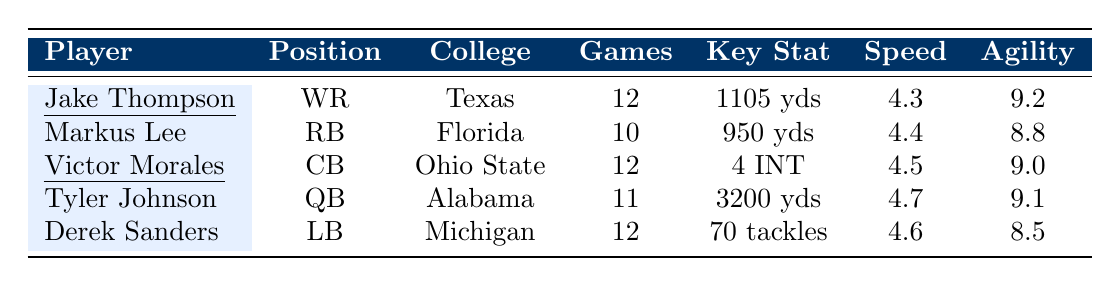What is the speed rating of Jake Thompson? The table provides a speed rating for each player. For Jake Thompson, the speed rating indicated in the row is 4.3.
Answer: 4.3 How many touchdowns did Tyler Johnson score? Looking at Tyler Johnson's row in the table, the number of touchdowns listed is 30.
Answer: 30 Which player had the most rushing attempts, and how many did they have? The table shows Markus Lee as the only player with rushing attempts listed, which is 180. None of the other players have this statistic, making him the player with the most attempts.
Answer: Markus Lee, 180 Who played the most games and how many games did they play? By examining the table, both Jake Thompson and Derek Sanders played 12 games, which is the highest number listed among all players.
Answer: Jake Thompson and Derek Sanders, 12 games What is the average tackles per game for Derek Sanders? The table provides an average tackles per game for Derek Sanders, which is stated as 5.8. This is the value we will use to answer the question.
Answer: 5.8 Is Jake Thompson's average yards per game higher than Markus Lee's? The average yards per game for Jake Thompson is 92, while Markus Lee's is 95. Since 92 < 95, Jake Thompson's average is not higher than Markus Lee's.
Answer: No How many total touchdowns were scored by the players listed in the table? To find the total touchdowns, we need to sum the touchdowns for each player. This gives us 12 (Thompson) + 8 (Lee) + 0 (Morales) + 30 (Johnson) + 1 (Sanders) = 51.
Answer: 51 Which player's agility rating is the highest and what is that value? Checking the agility ratings in the table, Jake Thompson has the highest rating at 9.2.
Answer: Jake Thompson, 9.2 Which position has the highest average yards per game based on the players listed? The average yards per game for each position is: Wide Receiver (92), Running Back (95), Quarterback (290), Cornerback (not applicable), and Linebacker (not applicable). The Quarterback position has the highest average yards per game at 290.
Answer: Quarterback, 290 If we consider only players who played 12 games, who had more touchdowns: Jake Thompson or Derek Sanders? The statistics show Jake Thompson recorded 12 touchdowns while Derek Sanders scored only 1. Since 12 > 1, Jake Thompson had more touchdowns.
Answer: Jake Thompson 